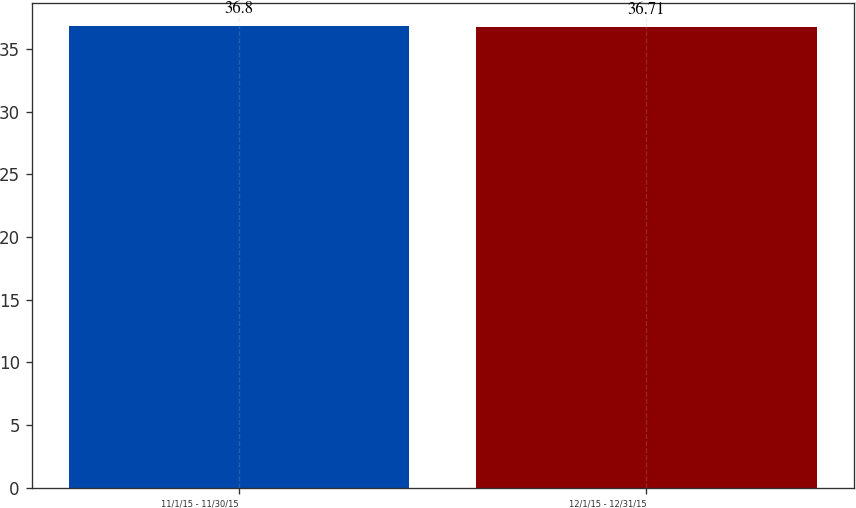Convert chart to OTSL. <chart><loc_0><loc_0><loc_500><loc_500><bar_chart><fcel>11/1/15 - 11/30/15<fcel>12/1/15 - 12/31/15<nl><fcel>36.8<fcel>36.71<nl></chart> 